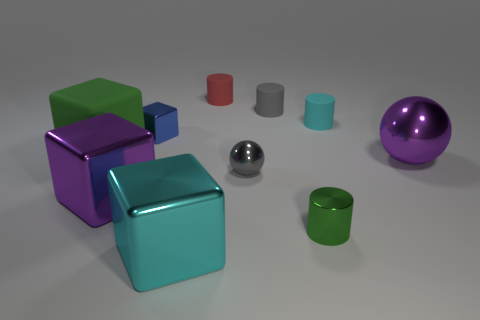What is the color of the cylinder that is in front of the large purple object that is on the right side of the tiny shiny thing that is to the left of the red rubber object? The color of the closest cylinder in front of the large purple object, which is situated to the right of the small reflective sphere and to the left of the red item that appears to have a rubber texture, is a shade of teal. 